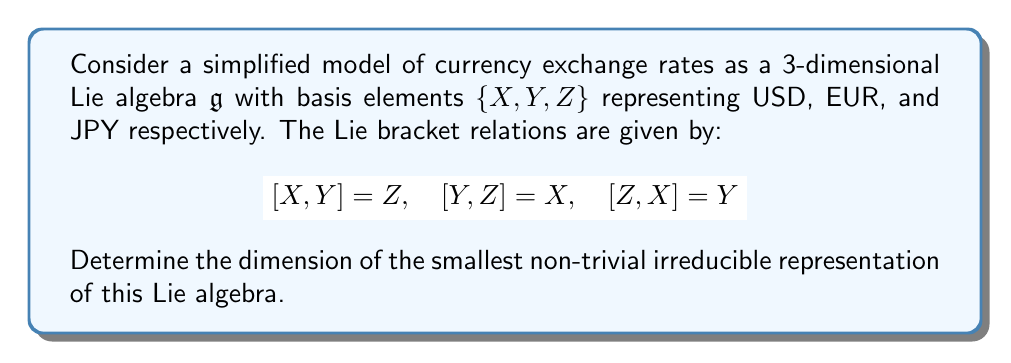Can you solve this math problem? To solve this problem, we'll follow these steps:

1) First, we recognize that the given Lie algebra $\mathfrak{g}$ is isomorphic to $\mathfrak{so}(3)$, the Lie algebra of 3x3 skew-symmetric matrices.

2) For $\mathfrak{so}(3)$, we know that the irreducible representations are characterized by their highest weight, which is a non-negative half-integer $j$.

3) The dimension of the irreducible representation with highest weight $j$ is given by $2j+1$.

4) The trivial representation corresponds to $j=0$, which has dimension 1.

5) Therefore, the smallest non-trivial irreducible representation will correspond to the next possible value of $j$, which is $j=\frac{1}{2}$.

6) Plugging $j=\frac{1}{2}$ into the dimension formula:

   $$\text{dim} = 2j + 1 = 2(\frac{1}{2}) + 1 = 2$$

Thus, the smallest non-trivial irreducible representation of this Lie algebra has dimension 2.
Answer: 2 